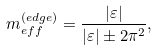<formula> <loc_0><loc_0><loc_500><loc_500>m _ { e f f } ^ { ( e d g e ) } = \frac { | \varepsilon | } { | \varepsilon | \pm 2 \pi ^ { 2 } } ,</formula> 